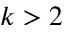<formula> <loc_0><loc_0><loc_500><loc_500>k > 2</formula> 